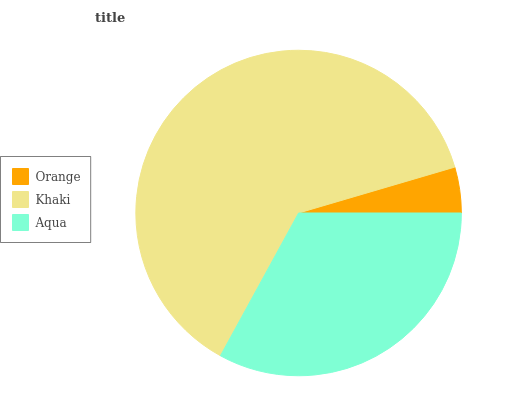Is Orange the minimum?
Answer yes or no. Yes. Is Khaki the maximum?
Answer yes or no. Yes. Is Aqua the minimum?
Answer yes or no. No. Is Aqua the maximum?
Answer yes or no. No. Is Khaki greater than Aqua?
Answer yes or no. Yes. Is Aqua less than Khaki?
Answer yes or no. Yes. Is Aqua greater than Khaki?
Answer yes or no. No. Is Khaki less than Aqua?
Answer yes or no. No. Is Aqua the high median?
Answer yes or no. Yes. Is Aqua the low median?
Answer yes or no. Yes. Is Orange the high median?
Answer yes or no. No. Is Khaki the low median?
Answer yes or no. No. 